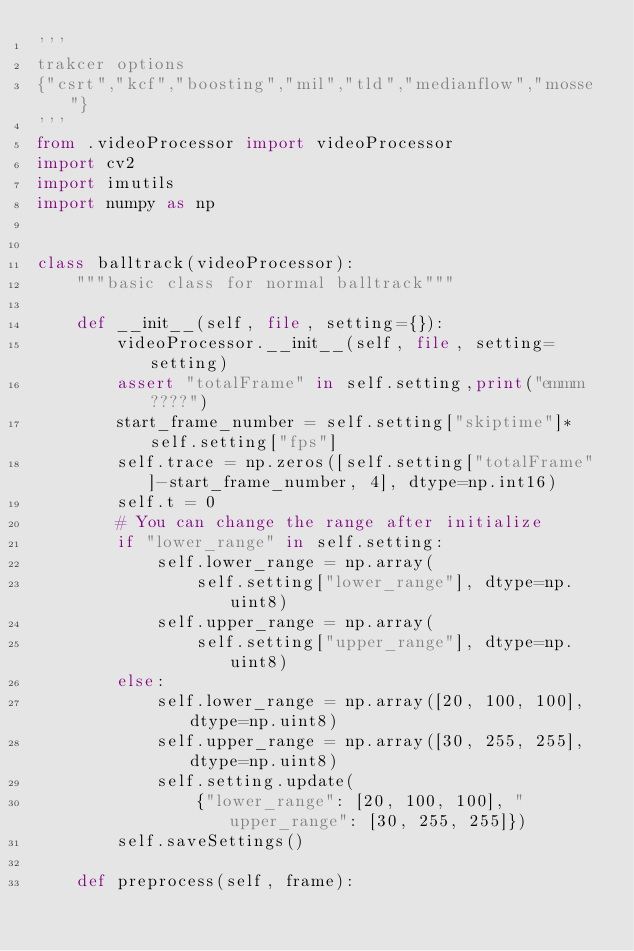<code> <loc_0><loc_0><loc_500><loc_500><_Python_>'''
trakcer options
{"csrt","kcf","boosting","mil","tld","medianflow","mosse"}
'''
from .videoProcessor import videoProcessor
import cv2
import imutils
import numpy as np


class balltrack(videoProcessor):
    """basic class for normal balltrack"""

    def __init__(self, file, setting={}):
        videoProcessor.__init__(self, file, setting=setting)
        assert "totalFrame" in self.setting,print("emmm????")
        start_frame_number = self.setting["skiptime"]*self.setting["fps"]
        self.trace = np.zeros([self.setting["totalFrame"]-start_frame_number, 4], dtype=np.int16)
        self.t = 0
        # You can change the range after initialize
        if "lower_range" in self.setting:
            self.lower_range = np.array(
                self.setting["lower_range"], dtype=np.uint8)
            self.upper_range = np.array(
                self.setting["upper_range"], dtype=np.uint8)
        else:
            self.lower_range = np.array([20, 100, 100], dtype=np.uint8)
            self.upper_range = np.array([30, 255, 255], dtype=np.uint8)
            self.setting.update(
                {"lower_range": [20, 100, 100], "upper_range": [30, 255, 255]})
        self.saveSettings()

    def preprocess(self, frame):</code> 